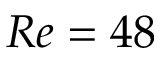Convert formula to latex. <formula><loc_0><loc_0><loc_500><loc_500>R e = 4 8</formula> 